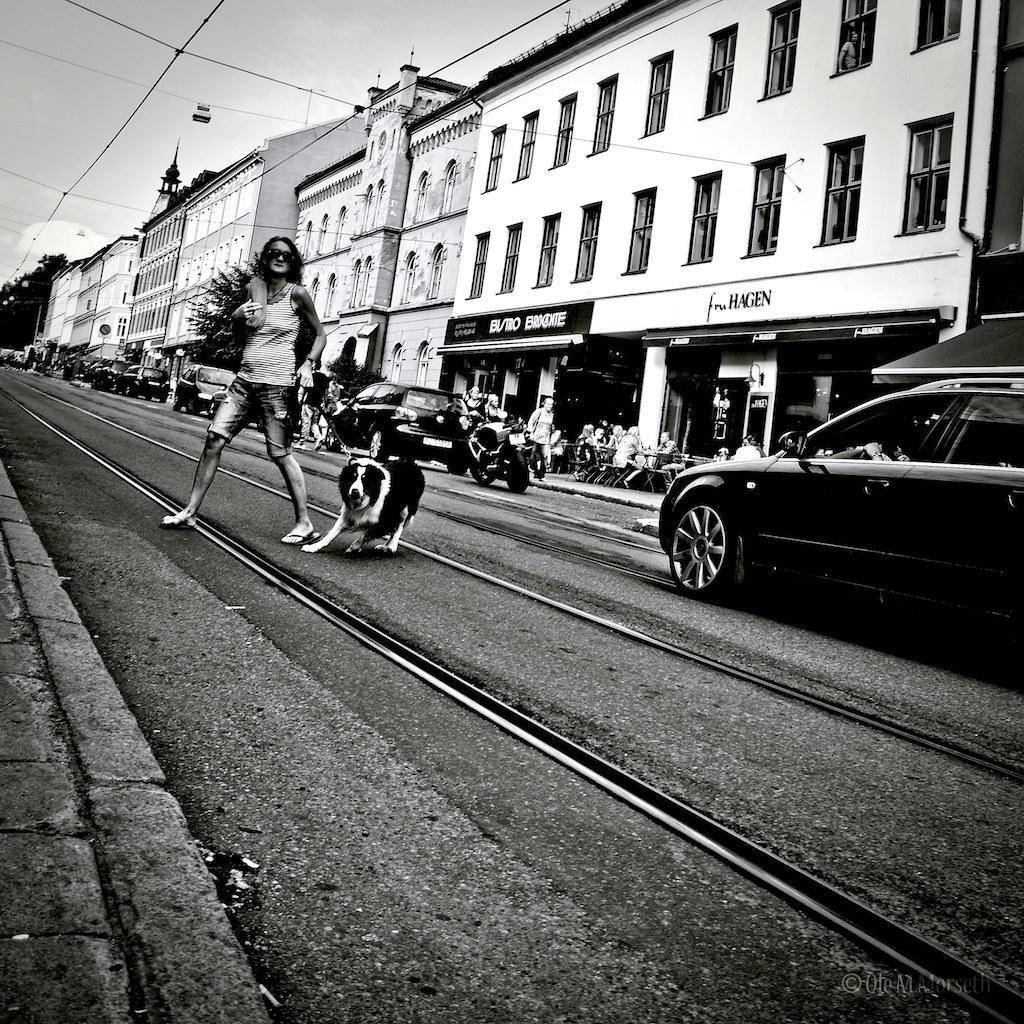Could you give a brief overview of what you see in this image? In this image there is the sky towards the top of the image, there are buildings towards the right of the image, there are windows, there is text on the building, there is a board, there is text on the board, there are a group of persons sitting on the chairs, there is road towards the bottom of the image, there are vehicles on the road, there is a woman walking on the road, she is holding an object, she is wearing a bag, there is a dog on the road. 